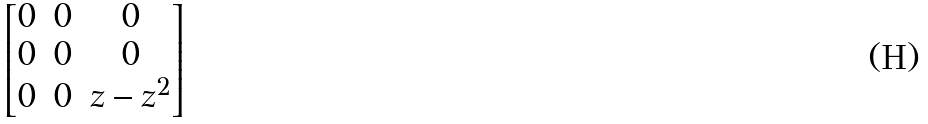<formula> <loc_0><loc_0><loc_500><loc_500>\begin{bmatrix} 0 & 0 & 0 \\ 0 & 0 & 0 \\ 0 & 0 & z - z ^ { 2 } \end{bmatrix}</formula> 